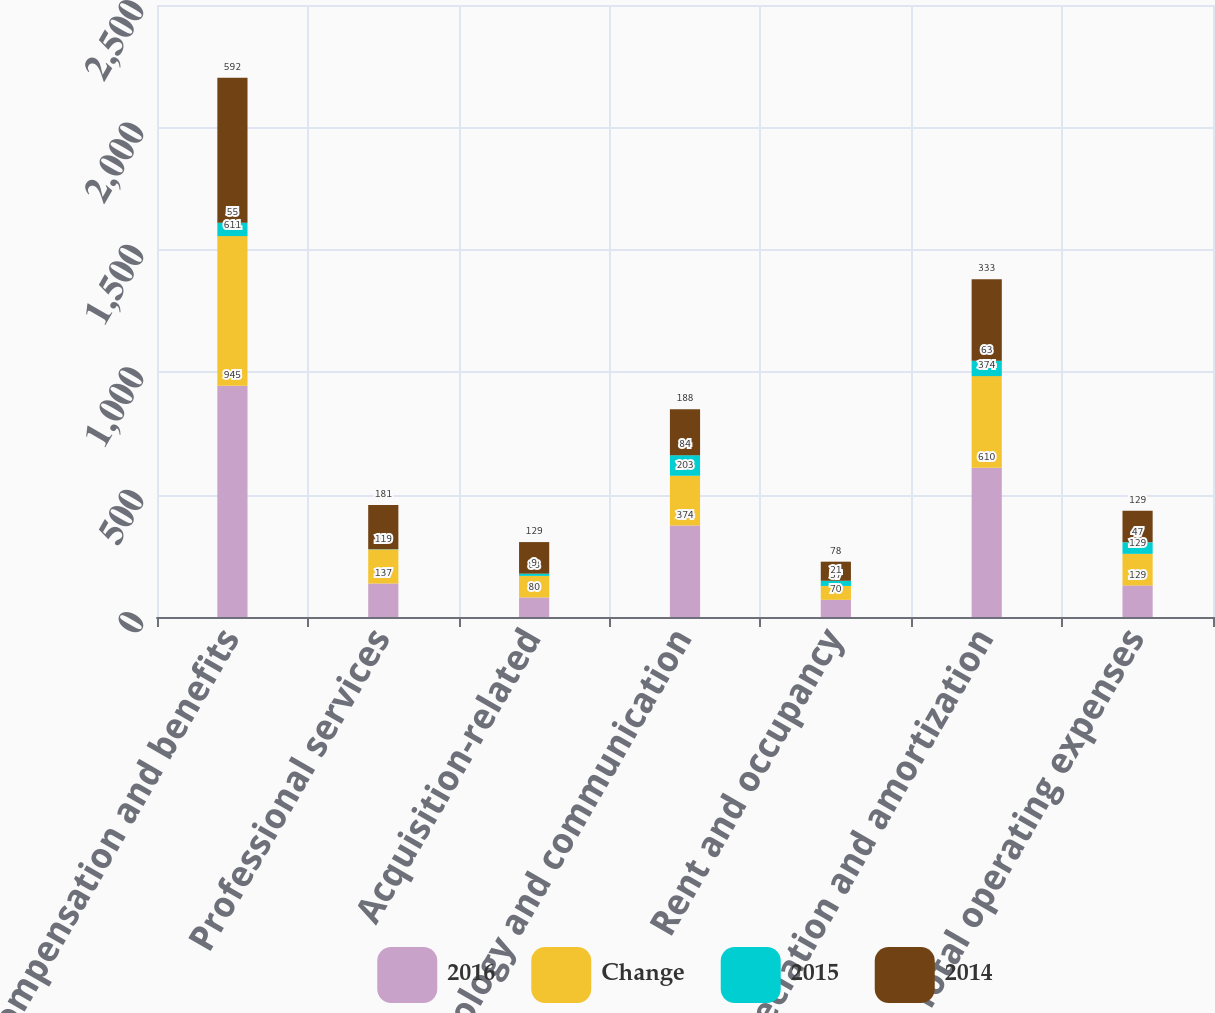Convert chart to OTSL. <chart><loc_0><loc_0><loc_500><loc_500><stacked_bar_chart><ecel><fcel>Compensation and benefits<fcel>Professional services<fcel>Acquisition-related<fcel>Technology and communication<fcel>Rent and occupancy<fcel>Depreciation and amortization<fcel>Total operating expenses<nl><fcel>2016<fcel>945<fcel>137<fcel>80<fcel>374<fcel>70<fcel>610<fcel>129<nl><fcel>Change<fcel>611<fcel>139<fcel>88<fcel>203<fcel>57<fcel>374<fcel>129<nl><fcel>2015<fcel>55<fcel>1<fcel>9<fcel>84<fcel>21<fcel>63<fcel>47<nl><fcel>2014<fcel>592<fcel>181<fcel>129<fcel>188<fcel>78<fcel>333<fcel>129<nl></chart> 